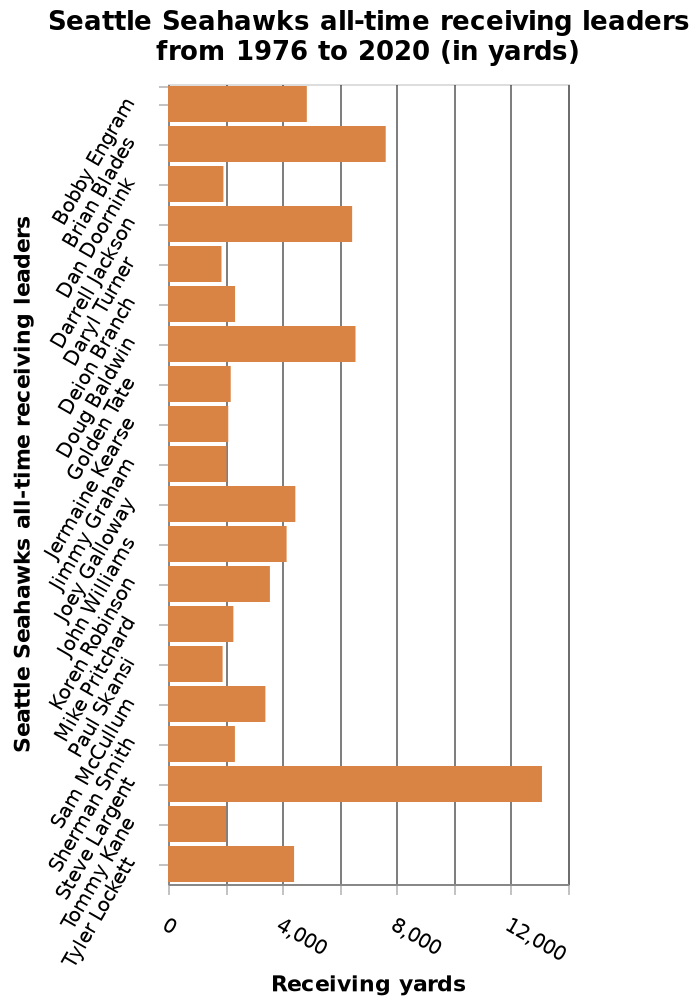<image>
Who is the minimum receiving leader for Seattle Seahawks all-time from 1976 to 2020?  The minimum receiving leader for Seattle Seahawks all-time from 1976 to 2020 is Bobby Engram. What scale is used for the y-axis in the bar graph showcasing Seattle Seahawks all-time receiving leaders? The y-axis in the bar graph showcasing Seattle Seahawks all-time receiving leaders is in categorical scale. What can be said about Steve Largent's yardage in comparison to others?  Steve Largent's yardage is significantly higher than others. Offer a thorough analysis of the image. Steve Largent received more yard compering with the others The difference is really high. Who is the maximum receiving leader for Seattle Seahawks all-time from 1976 to 2020?  The maximum receiving leader for Seattle Seahawks all-time from 1976 to 2020 is currently unknown as it is not mentioned in the description. How does Steve Largent's yardage compare to others?  The difference is really high between Steve Largent's yardage and others. Is the maximum receiving leader for Seattle Seahawks all-time from 1976 to 2020 Bobby Engram? No. The minimum receiving leader for Seattle Seahawks all-time from 1976 to 2020 is Bobby Engram. 